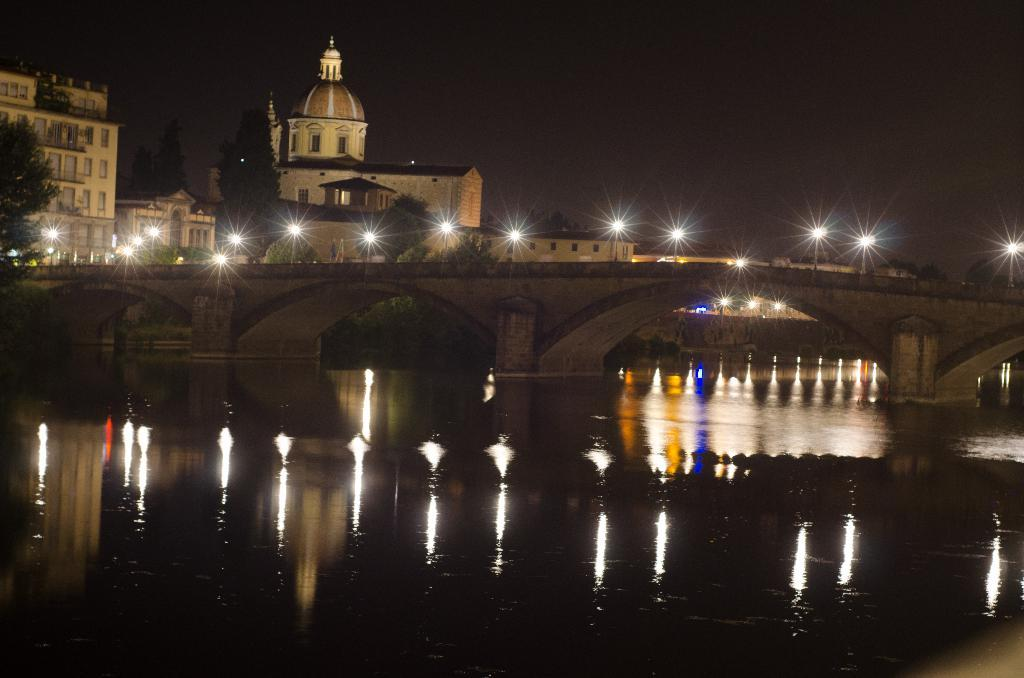What body of water is present in the image? There is a river in the image. How does the river connect the two sides of the image? There is a bridge over the river. What feature of the bridge is mentioned in the facts? The bridge has lights on it. What can be seen on the other side of the bridge? There are trees and buildings on the other side of the bridge. What type of loaf is being used to build the bridge in the image? There is no loaf present in the image; the bridge is not made of any type of loaf. 